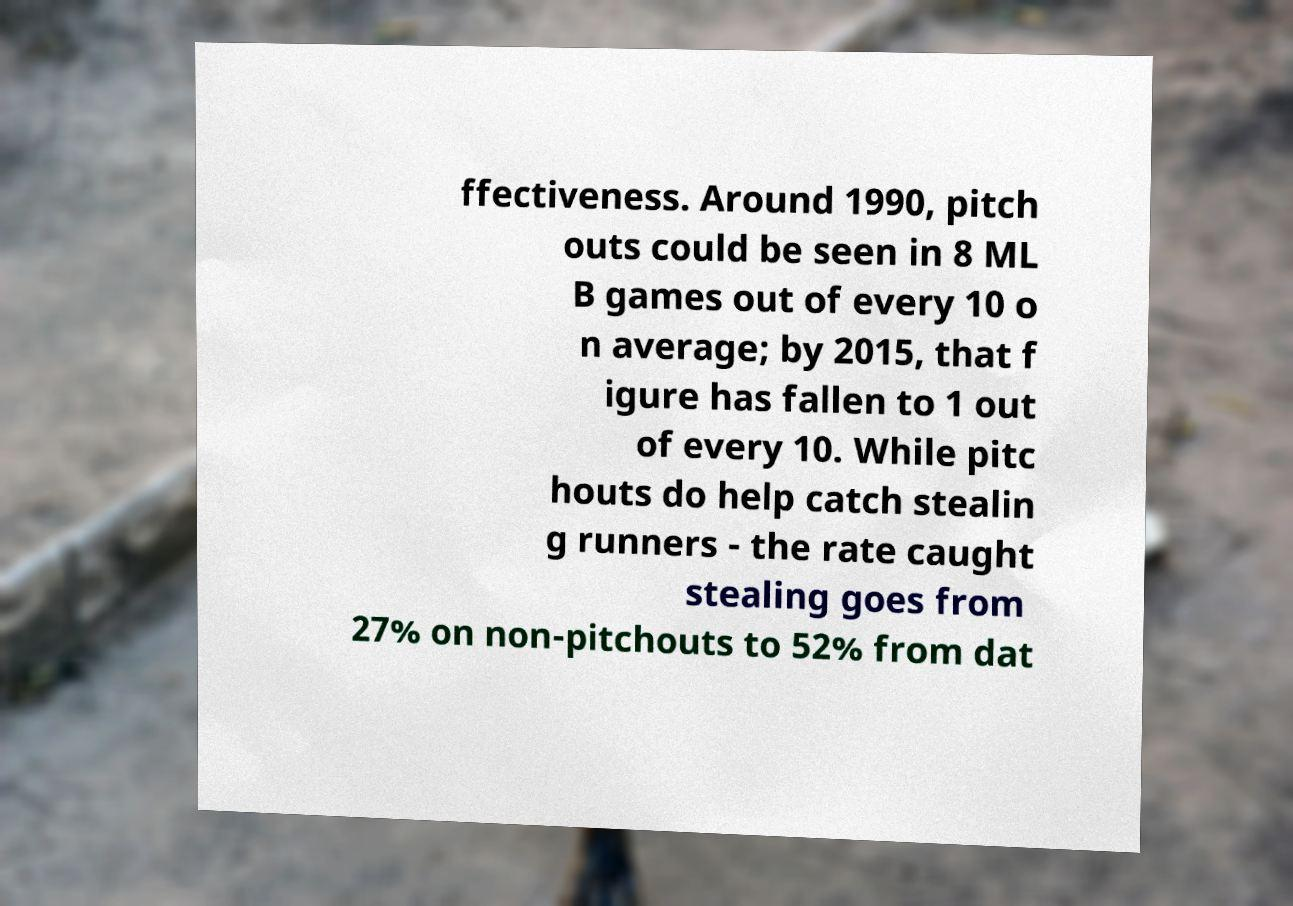Could you extract and type out the text from this image? ffectiveness. Around 1990, pitch outs could be seen in 8 ML B games out of every 10 o n average; by 2015, that f igure has fallen to 1 out of every 10. While pitc houts do help catch stealin g runners - the rate caught stealing goes from 27% on non-pitchouts to 52% from dat 